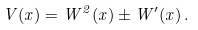Convert formula to latex. <formula><loc_0><loc_0><loc_500><loc_500>V ( x ) = W ^ { 2 } ( x ) \pm W ^ { \prime } ( x ) \, .</formula> 